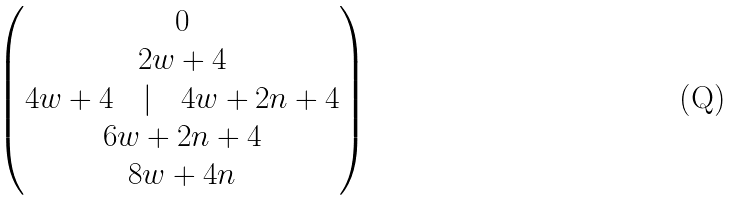<formula> <loc_0><loc_0><loc_500><loc_500>\begin{pmatrix} 0 \\ 2 w + 4 \\ 4 w + 4 \quad | \quad 4 w + 2 n + 4 \\ 6 w + 2 n + 4 \\ 8 w + 4 n \end{pmatrix}</formula> 